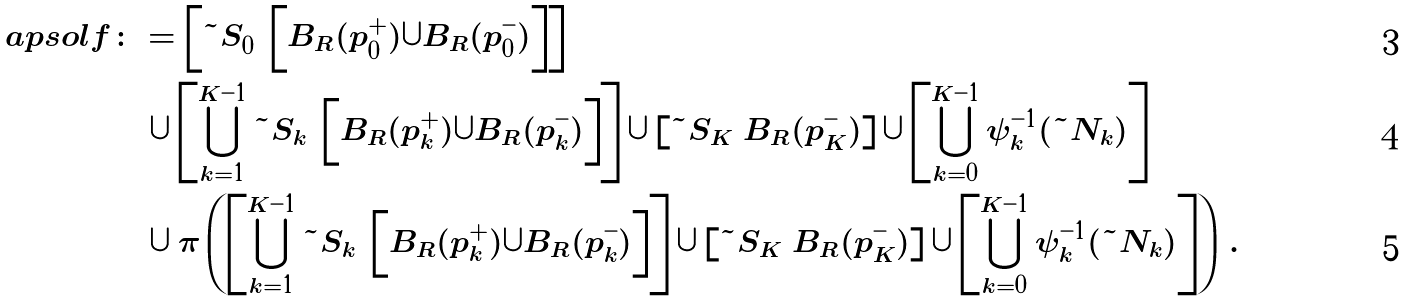Convert formula to latex. <formula><loc_0><loc_0><loc_500><loc_500>\ a p s o l f & \colon = \left [ \tilde { S } _ { 0 } \ \left [ B _ { R } ( p _ { 0 } ^ { + } ) \cup B _ { R } ( p _ { 0 } ^ { - } ) \right ] \right ] \\ & \quad \cup \left [ \bigcup _ { k = 1 } ^ { K - 1 } \tilde { S } _ { k } \ \left [ B _ { R } ( p _ { k } ^ { + } ) \cup B _ { R } ( p _ { k } ^ { - } ) \right ] \right ] \cup \left [ \tilde { S } _ { K } \ B _ { R } ( p _ { K } ^ { - } ) \right ] \cup \left [ \bigcup _ { \substack { k = 0 } } ^ { K - 1 } \psi _ { k } ^ { - 1 } ( \tilde { N } _ { k } ) \right ] \\ & \quad \cup \pi \left ( \left [ \bigcup _ { k = 1 } ^ { K - 1 } \tilde { S } _ { k } \ \left [ B _ { R } ( p _ { k } ^ { + } ) \cup B _ { R } ( p _ { k } ^ { - } ) \right ] \right ] \cup \left [ \tilde { S } _ { K } \ B _ { R } ( p _ { K } ^ { - } ) \right ] \cup \left [ \bigcup _ { \substack { k = 0 } } ^ { K - 1 } \psi _ { k } ^ { - 1 } ( \tilde { N } _ { k } ) \right ] \right ) \, .</formula> 